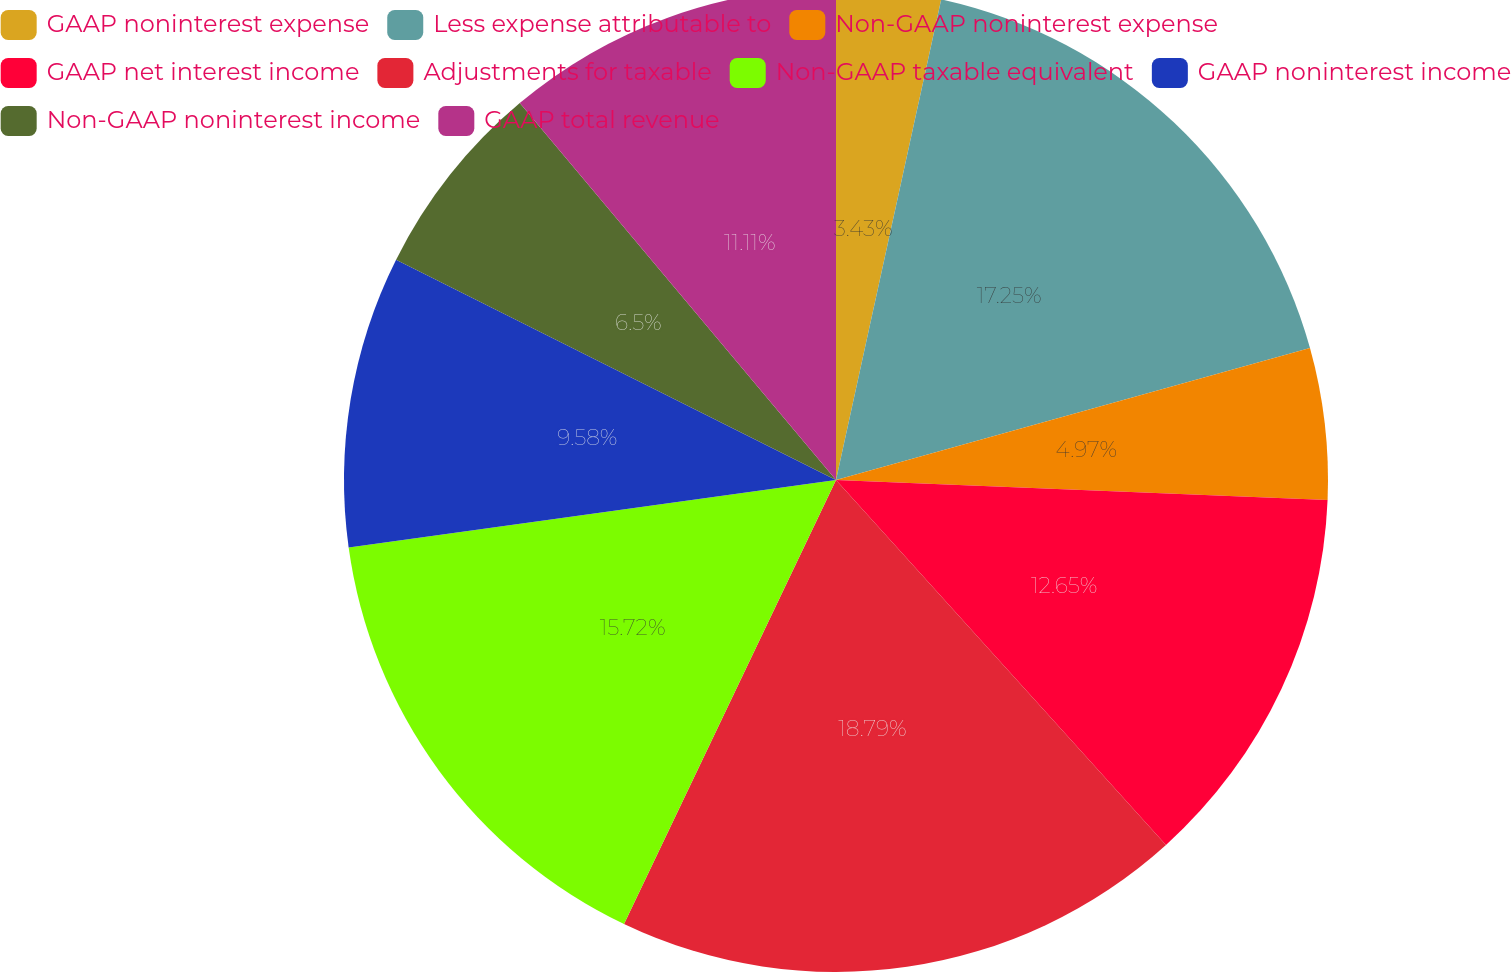<chart> <loc_0><loc_0><loc_500><loc_500><pie_chart><fcel>GAAP noninterest expense<fcel>Less expense attributable to<fcel>Non-GAAP noninterest expense<fcel>GAAP net interest income<fcel>Adjustments for taxable<fcel>Non-GAAP taxable equivalent<fcel>GAAP noninterest income<fcel>Non-GAAP noninterest income<fcel>GAAP total revenue<nl><fcel>3.43%<fcel>17.25%<fcel>4.97%<fcel>12.65%<fcel>18.79%<fcel>15.72%<fcel>9.58%<fcel>6.5%<fcel>11.11%<nl></chart> 